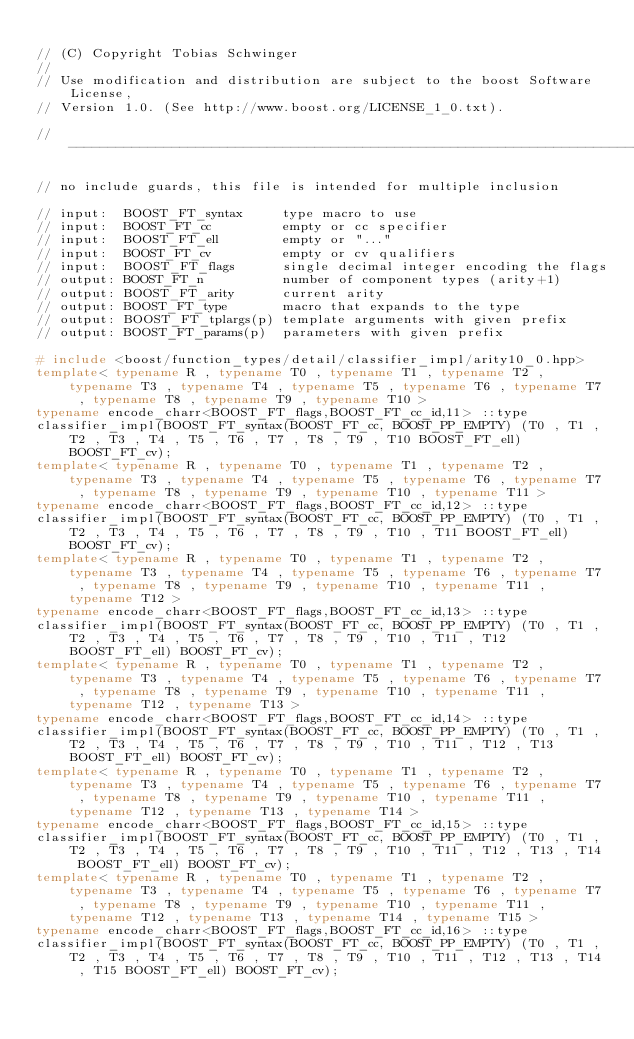<code> <loc_0><loc_0><loc_500><loc_500><_C++_>
// (C) Copyright Tobias Schwinger
//
// Use modification and distribution are subject to the boost Software License,
// Version 1.0. (See http://www.boost.org/LICENSE_1_0.txt).

//------------------------------------------------------------------------------

// no include guards, this file is intended for multiple inclusion

// input:  BOOST_FT_syntax     type macro to use
// input:  BOOST_FT_cc         empty or cc specifier 
// input:  BOOST_FT_ell        empty or "..."
// input:  BOOST_FT_cv         empty or cv qualifiers
// input:  BOOST_FT_flags      single decimal integer encoding the flags
// output: BOOST_FT_n          number of component types (arity+1)
// output: BOOST_FT_arity      current arity
// output: BOOST_FT_type       macro that expands to the type
// output: BOOST_FT_tplargs(p) template arguments with given prefix
// output: BOOST_FT_params(p)  parameters with given prefix

# include <boost/function_types/detail/classifier_impl/arity10_0.hpp>
template< typename R , typename T0 , typename T1 , typename T2 , typename T3 , typename T4 , typename T5 , typename T6 , typename T7 , typename T8 , typename T9 , typename T10 >
typename encode_charr<BOOST_FT_flags,BOOST_FT_cc_id,11> ::type
classifier_impl(BOOST_FT_syntax(BOOST_FT_cc, BOOST_PP_EMPTY) (T0 , T1 , T2 , T3 , T4 , T5 , T6 , T7 , T8 , T9 , T10 BOOST_FT_ell) BOOST_FT_cv);
template< typename R , typename T0 , typename T1 , typename T2 , typename T3 , typename T4 , typename T5 , typename T6 , typename T7 , typename T8 , typename T9 , typename T10 , typename T11 >
typename encode_charr<BOOST_FT_flags,BOOST_FT_cc_id,12> ::type
classifier_impl(BOOST_FT_syntax(BOOST_FT_cc, BOOST_PP_EMPTY) (T0 , T1 , T2 , T3 , T4 , T5 , T6 , T7 , T8 , T9 , T10 , T11 BOOST_FT_ell) BOOST_FT_cv);
template< typename R , typename T0 , typename T1 , typename T2 , typename T3 , typename T4 , typename T5 , typename T6 , typename T7 , typename T8 , typename T9 , typename T10 , typename T11 , typename T12 >
typename encode_charr<BOOST_FT_flags,BOOST_FT_cc_id,13> ::type
classifier_impl(BOOST_FT_syntax(BOOST_FT_cc, BOOST_PP_EMPTY) (T0 , T1 , T2 , T3 , T4 , T5 , T6 , T7 , T8 , T9 , T10 , T11 , T12 BOOST_FT_ell) BOOST_FT_cv);
template< typename R , typename T0 , typename T1 , typename T2 , typename T3 , typename T4 , typename T5 , typename T6 , typename T7 , typename T8 , typename T9 , typename T10 , typename T11 , typename T12 , typename T13 >
typename encode_charr<BOOST_FT_flags,BOOST_FT_cc_id,14> ::type
classifier_impl(BOOST_FT_syntax(BOOST_FT_cc, BOOST_PP_EMPTY) (T0 , T1 , T2 , T3 , T4 , T5 , T6 , T7 , T8 , T9 , T10 , T11 , T12 , T13 BOOST_FT_ell) BOOST_FT_cv);
template< typename R , typename T0 , typename T1 , typename T2 , typename T3 , typename T4 , typename T5 , typename T6 , typename T7 , typename T8 , typename T9 , typename T10 , typename T11 , typename T12 , typename T13 , typename T14 >
typename encode_charr<BOOST_FT_flags,BOOST_FT_cc_id,15> ::type
classifier_impl(BOOST_FT_syntax(BOOST_FT_cc, BOOST_PP_EMPTY) (T0 , T1 , T2 , T3 , T4 , T5 , T6 , T7 , T8 , T9 , T10 , T11 , T12 , T13 , T14 BOOST_FT_ell) BOOST_FT_cv);
template< typename R , typename T0 , typename T1 , typename T2 , typename T3 , typename T4 , typename T5 , typename T6 , typename T7 , typename T8 , typename T9 , typename T10 , typename T11 , typename T12 , typename T13 , typename T14 , typename T15 >
typename encode_charr<BOOST_FT_flags,BOOST_FT_cc_id,16> ::type
classifier_impl(BOOST_FT_syntax(BOOST_FT_cc, BOOST_PP_EMPTY) (T0 , T1 , T2 , T3 , T4 , T5 , T6 , T7 , T8 , T9 , T10 , T11 , T12 , T13 , T14 , T15 BOOST_FT_ell) BOOST_FT_cv);</code> 